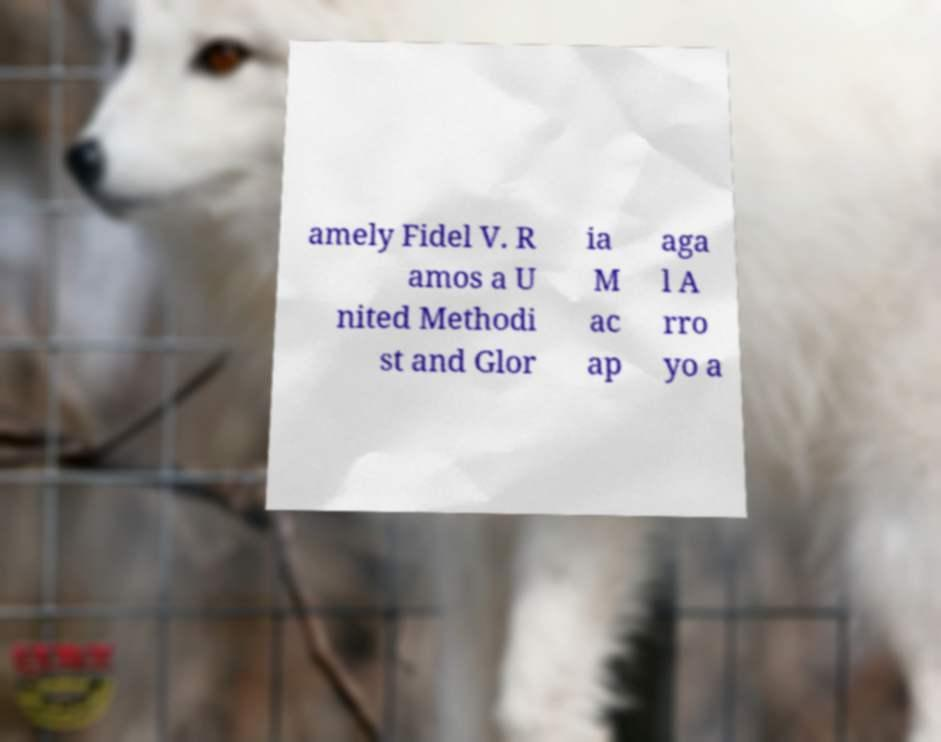Could you extract and type out the text from this image? amely Fidel V. R amos a U nited Methodi st and Glor ia M ac ap aga l A rro yo a 